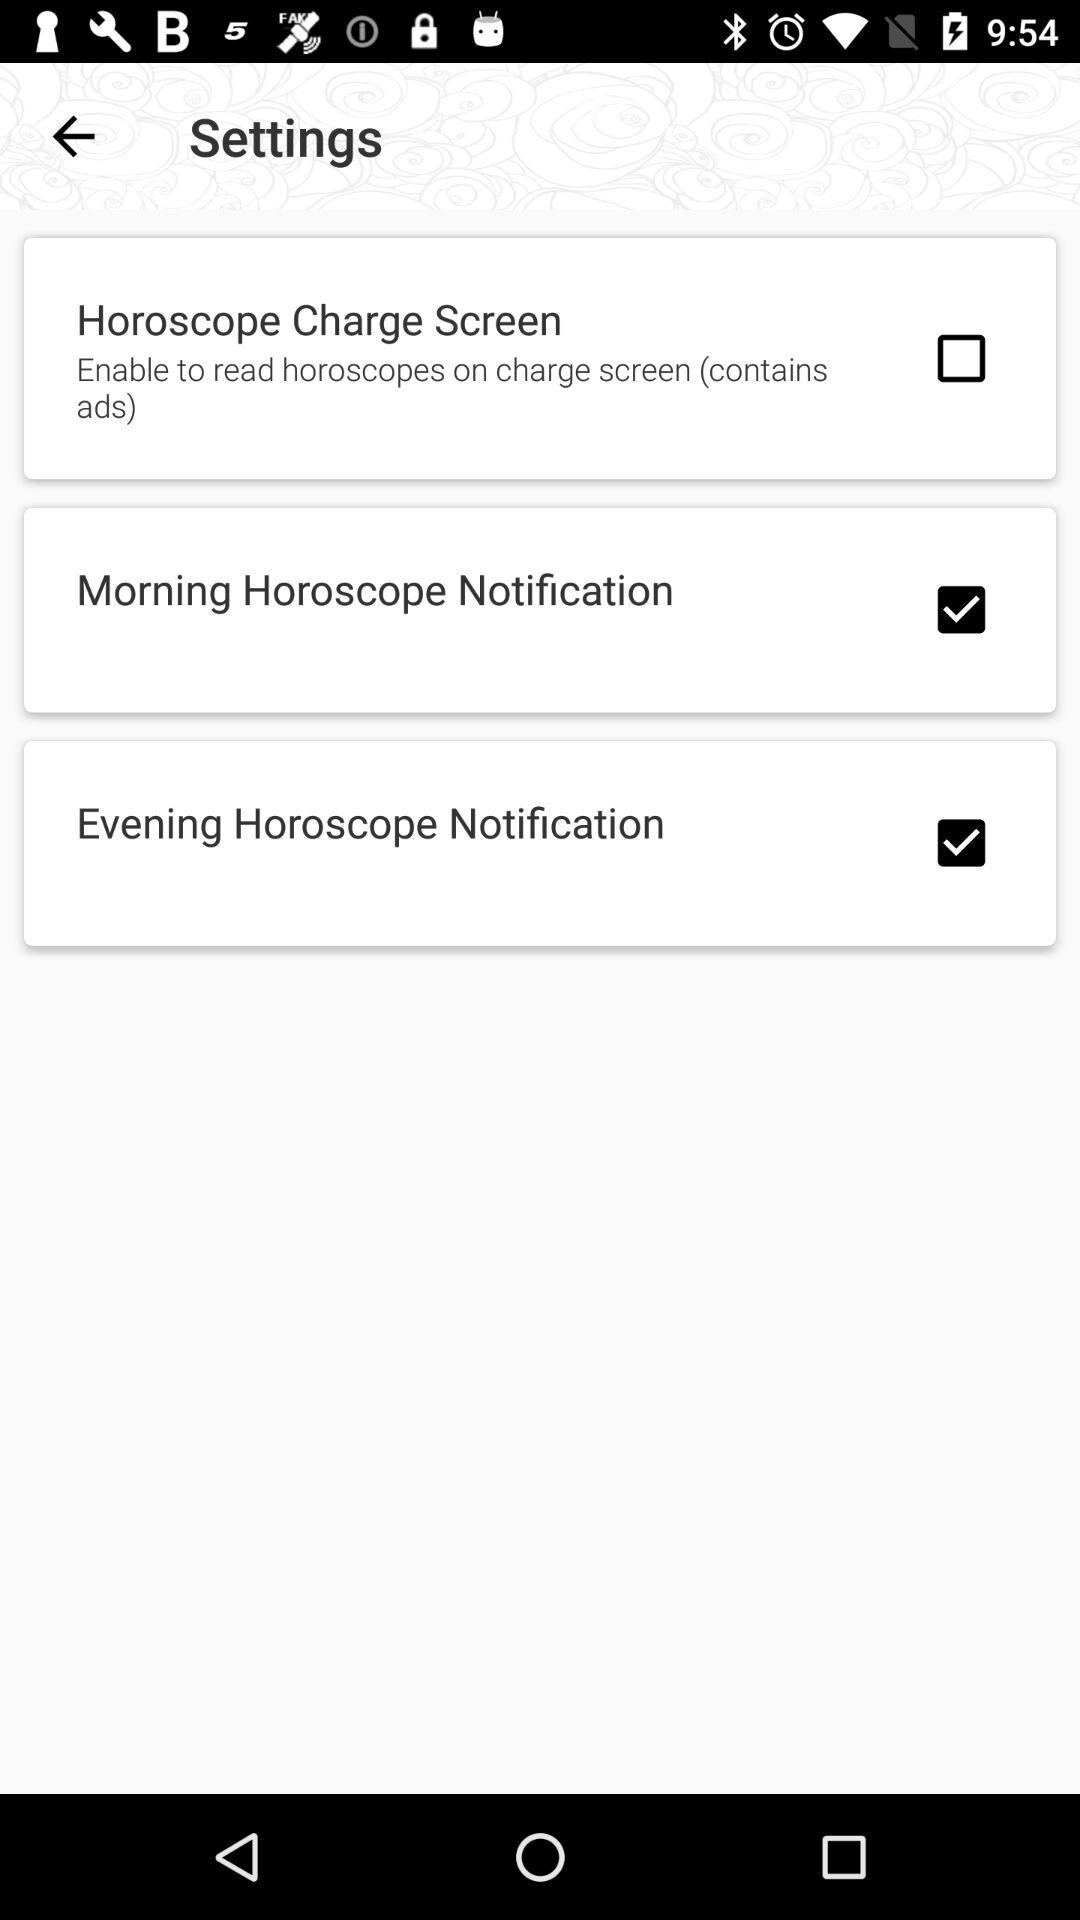Which notification settings are checked? The checked notification settings are "Morning Horoscope Notification" and "Evening Horoscope Notification". 